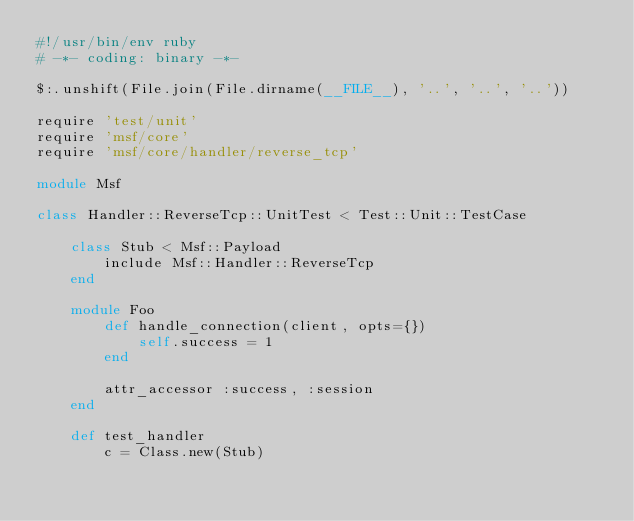<code> <loc_0><loc_0><loc_500><loc_500><_Ruby_>#!/usr/bin/env ruby
# -*- coding: binary -*-

$:.unshift(File.join(File.dirname(__FILE__), '..', '..', '..'))

require 'test/unit'
require 'msf/core'
require 'msf/core/handler/reverse_tcp'

module Msf

class Handler::ReverseTcp::UnitTest < Test::Unit::TestCase

	class Stub < Msf::Payload
		include Msf::Handler::ReverseTcp
	end

	module Foo
		def handle_connection(client, opts={})
			self.success = 1
		end

		attr_accessor :success, :session
	end

	def test_handler
		c = Class.new(Stub)</code> 